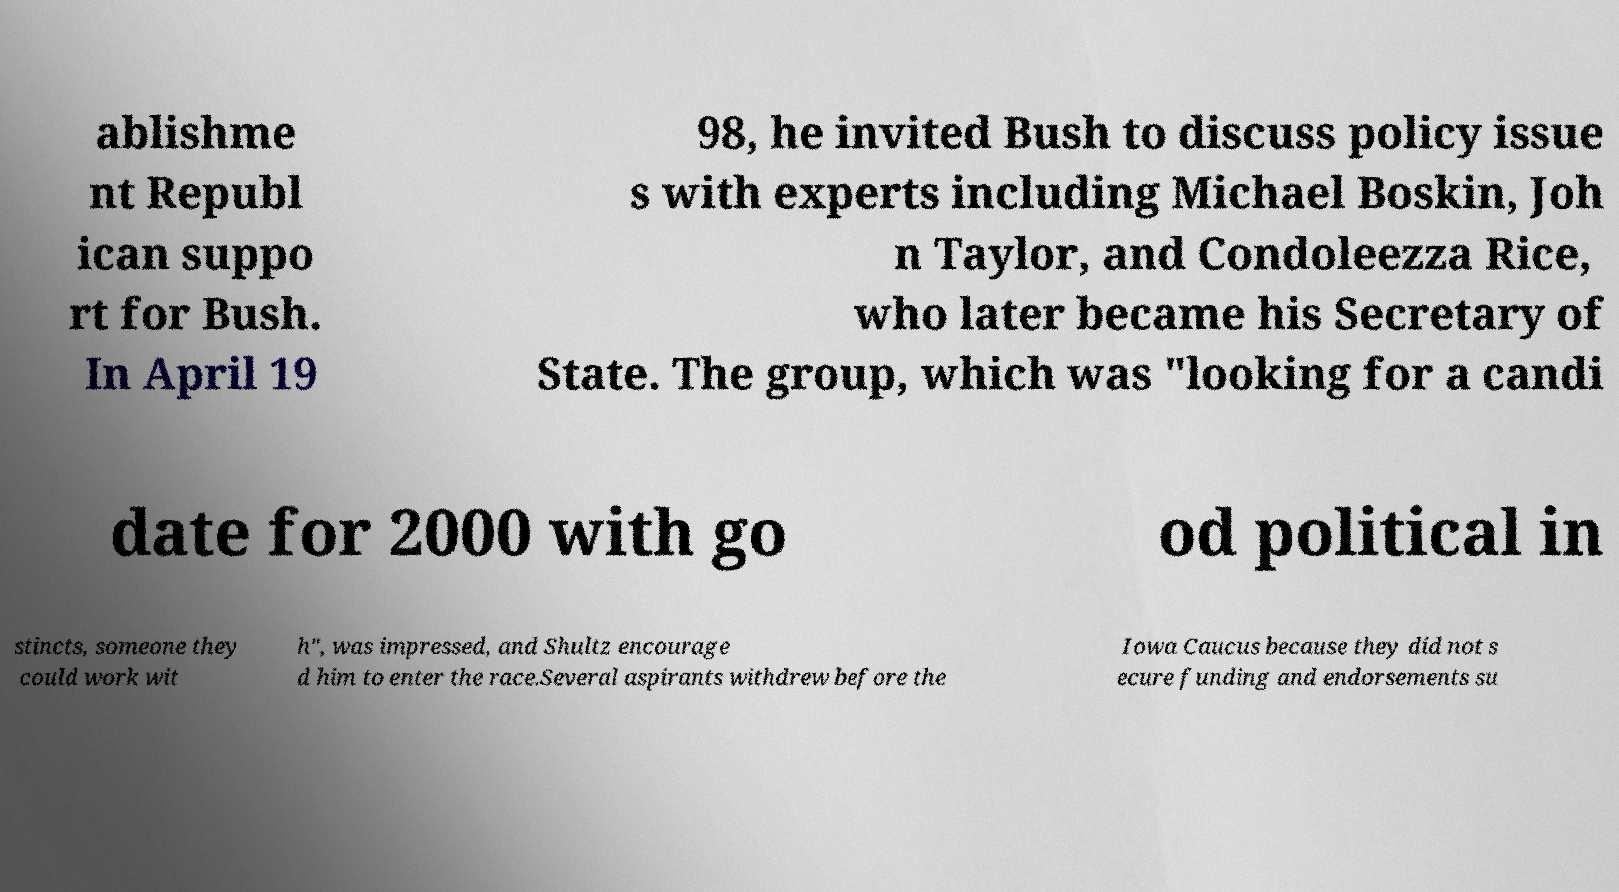Can you accurately transcribe the text from the provided image for me? ablishme nt Republ ican suppo rt for Bush. In April 19 98, he invited Bush to discuss policy issue s with experts including Michael Boskin, Joh n Taylor, and Condoleezza Rice, who later became his Secretary of State. The group, which was "looking for a candi date for 2000 with go od political in stincts, someone they could work wit h", was impressed, and Shultz encourage d him to enter the race.Several aspirants withdrew before the Iowa Caucus because they did not s ecure funding and endorsements su 